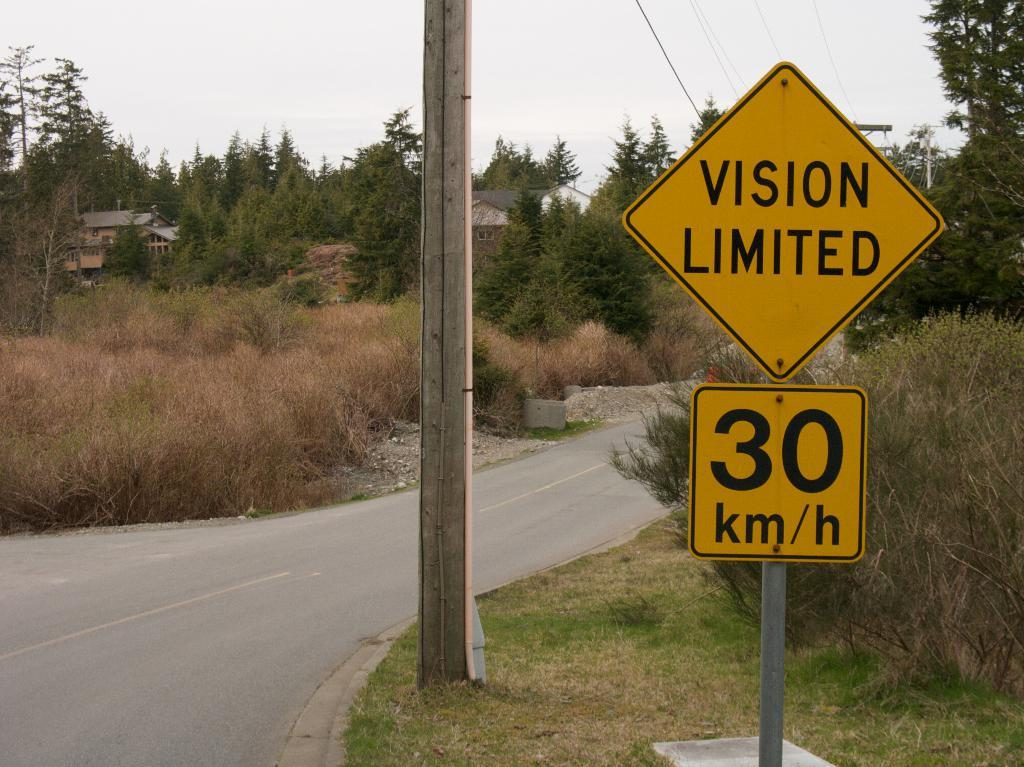<image>
Offer a succinct explanation of the picture presented. A sign warns drivers they may have trouble seeing on this road. 